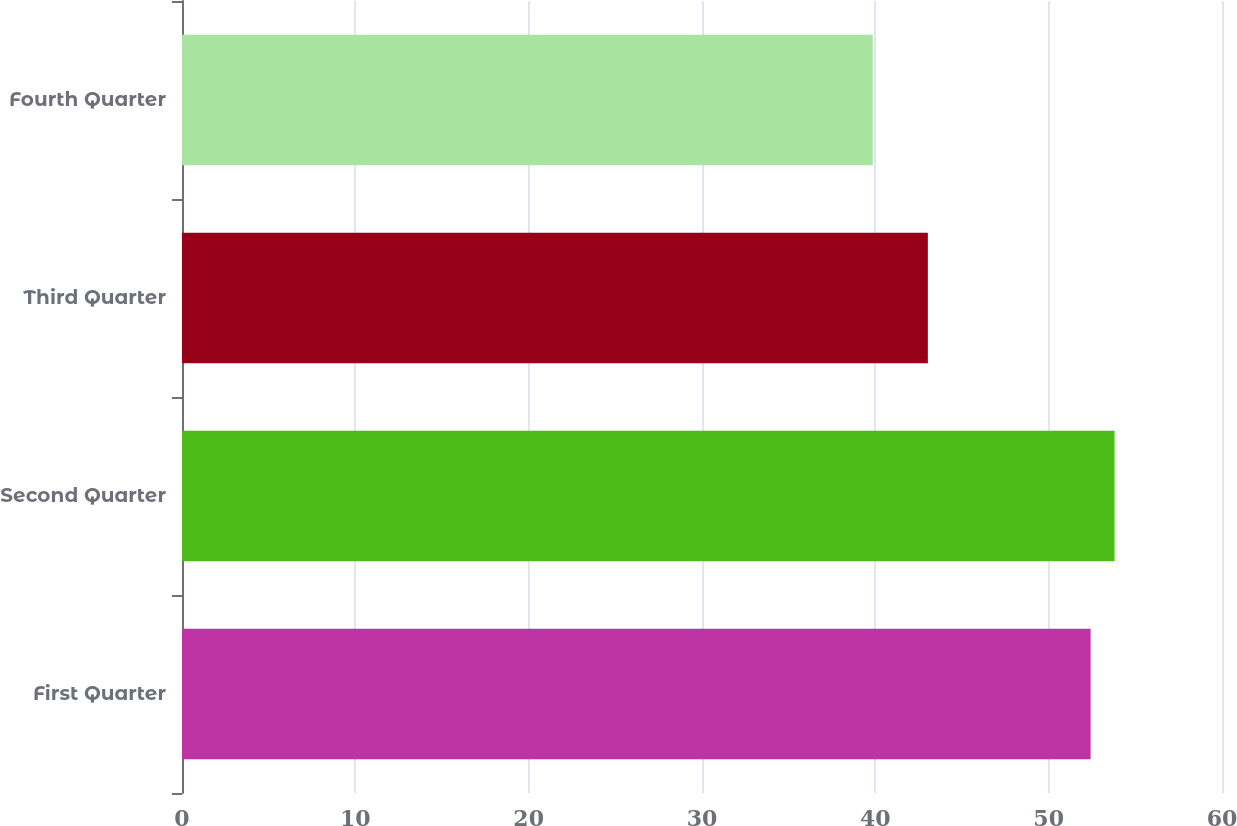Convert chart to OTSL. <chart><loc_0><loc_0><loc_500><loc_500><bar_chart><fcel>First Quarter<fcel>Second Quarter<fcel>Third Quarter<fcel>Fourth Quarter<nl><fcel>52.42<fcel>53.8<fcel>43.03<fcel>39.85<nl></chart> 